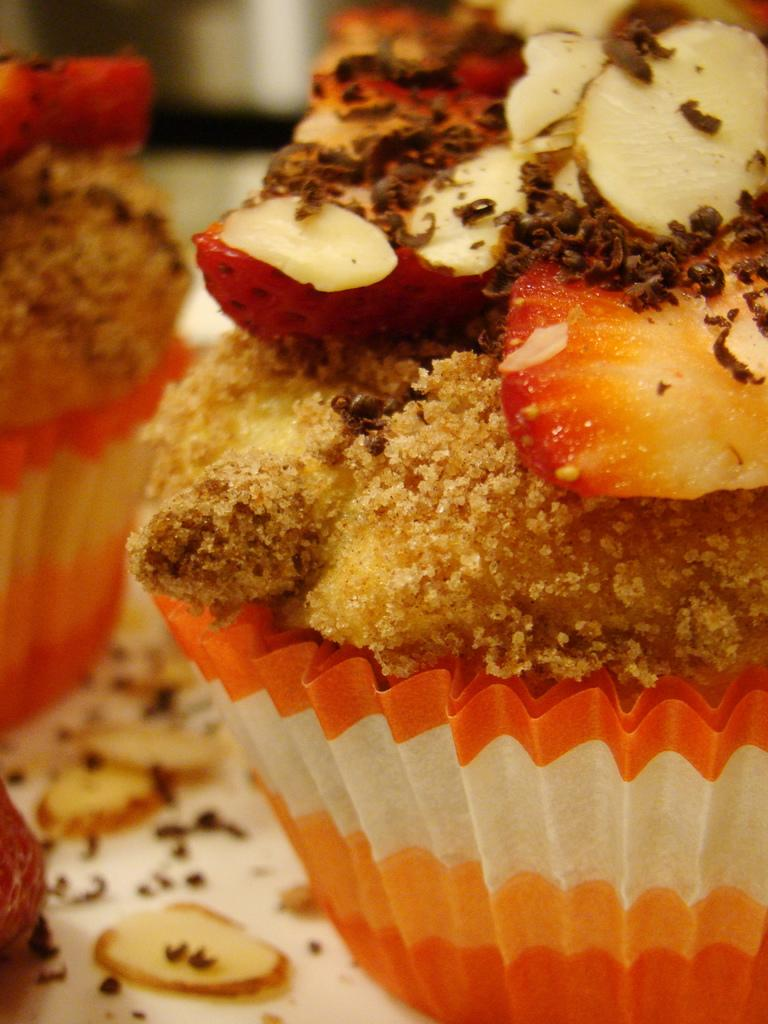What type of dessert can be seen in the image? There are cupcakes in the image. What else is present on the table in the image? There are other food items on the table in the image. What type of hospital is depicted in the image? There is no hospital present in the image; it features cupcakes and other food items on a table. What country is the image taken in? The image does not provide any information about the country in which it was taken. 